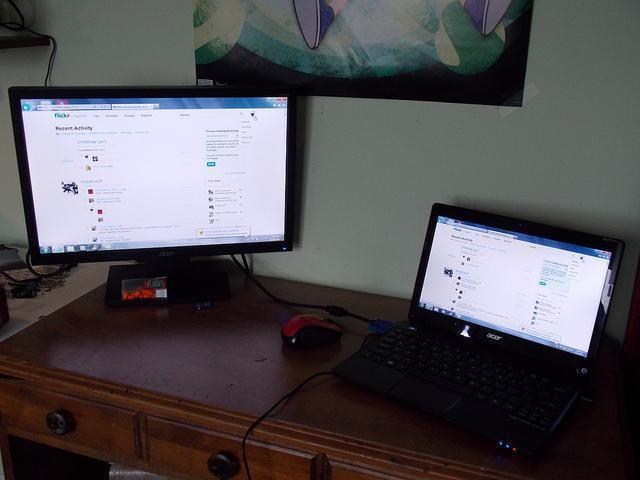How many trains are in the picture?
Give a very brief answer. 0. 